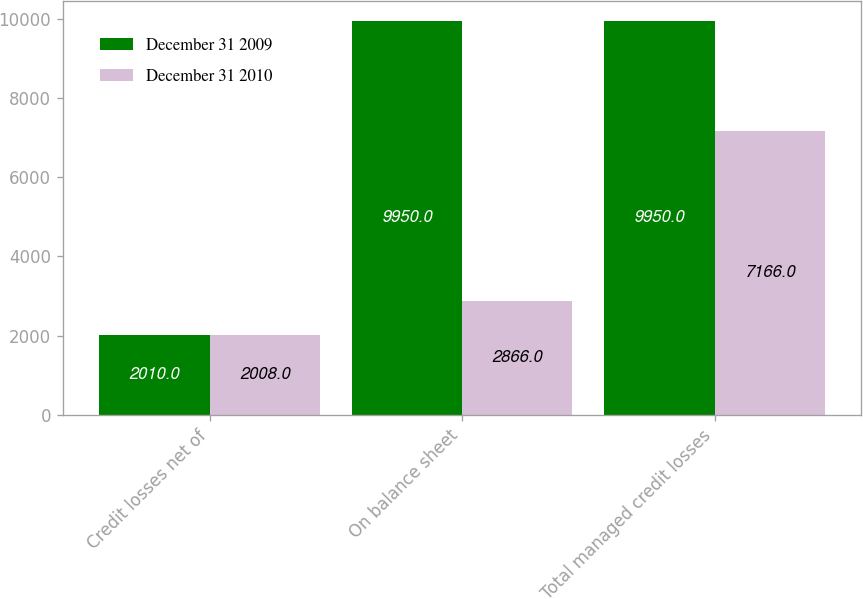Convert chart to OTSL. <chart><loc_0><loc_0><loc_500><loc_500><stacked_bar_chart><ecel><fcel>Credit losses net of<fcel>On balance sheet<fcel>Total managed credit losses<nl><fcel>December 31 2009<fcel>2010<fcel>9950<fcel>9950<nl><fcel>December 31 2010<fcel>2008<fcel>2866<fcel>7166<nl></chart> 